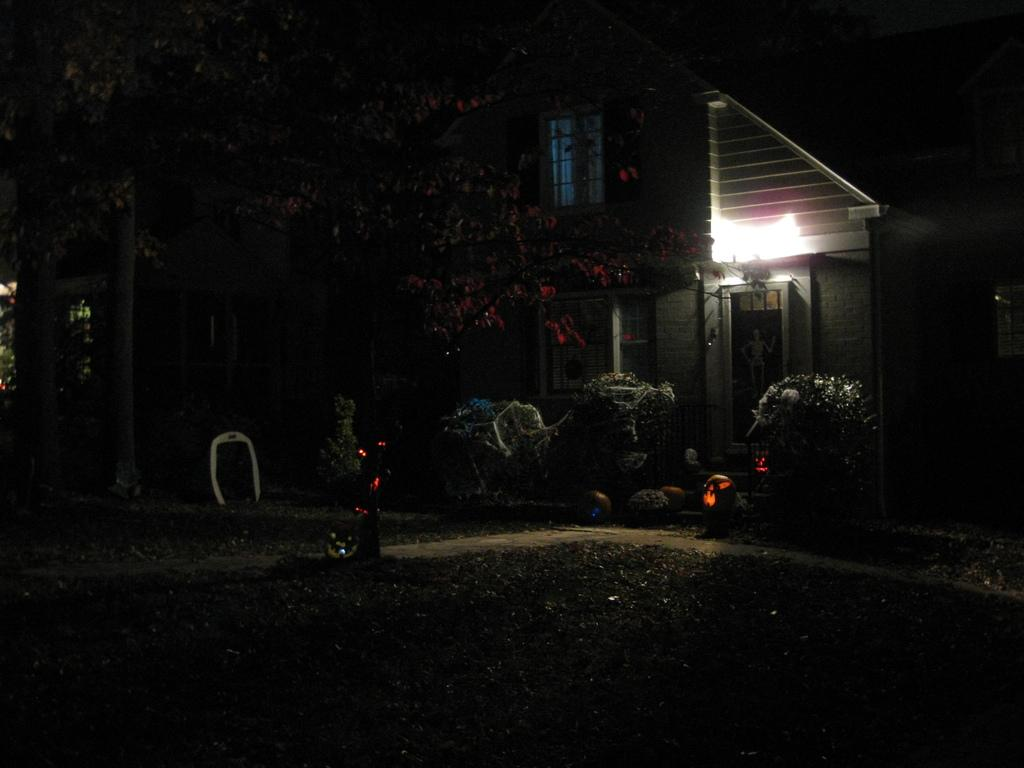What time of day was the image taken? The image was taken at night. What can be seen in the background of the image? There is a building in the background of the image. What is located in front of the building? There are plants and trees in front of the building. Can you describe the area in front of the building? There is a garden in the front of the building. What type of canvas is being used by the person in the image? There is no person in the image, nor is there any canvas present. 